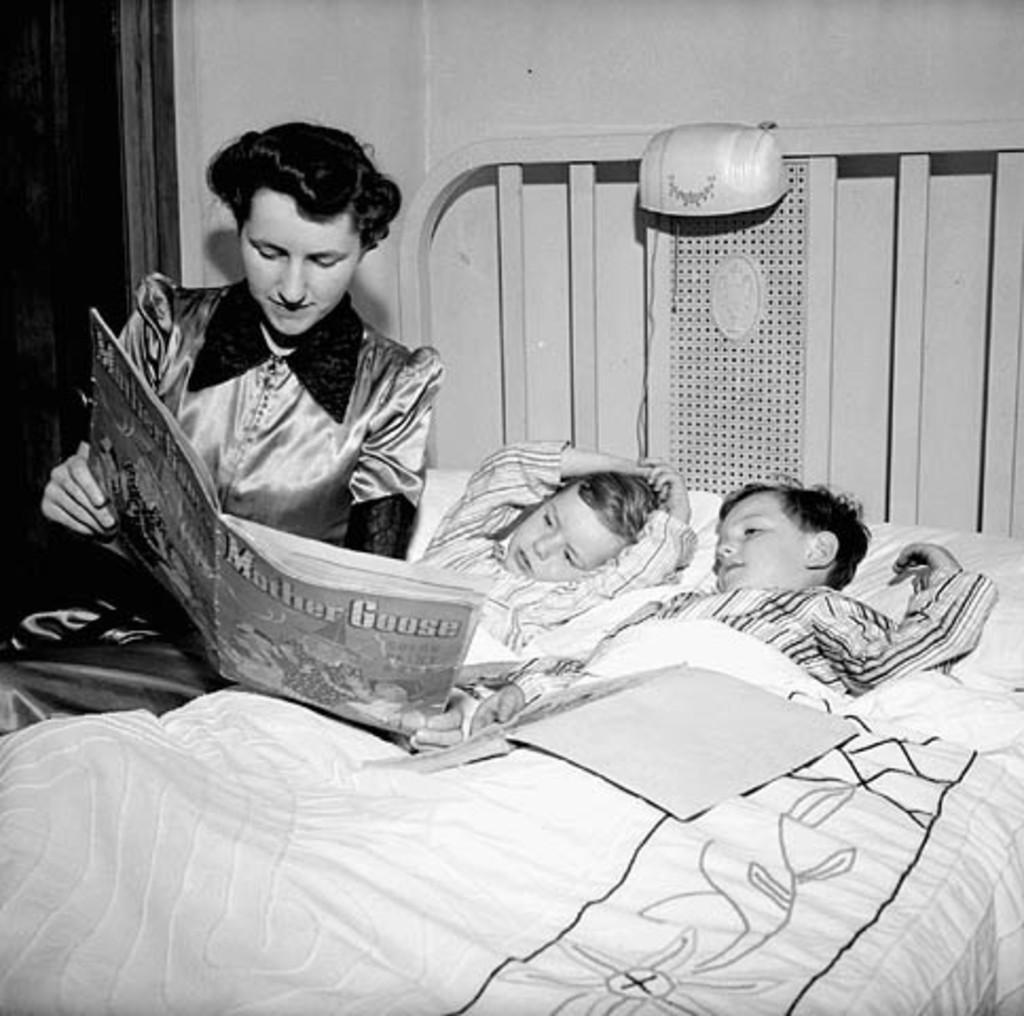Please provide a concise description of this image. The picture is clicked inside a room. there are two kids sleeping on a bed. Beside them a lady is sitting she is holding a book. In the background there is a wall. On the left top corner there is a door. 